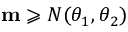Convert formula to latex. <formula><loc_0><loc_0><loc_500><loc_500>m \geqslant N ( \theta _ { 1 } , \theta _ { 2 } )</formula> 